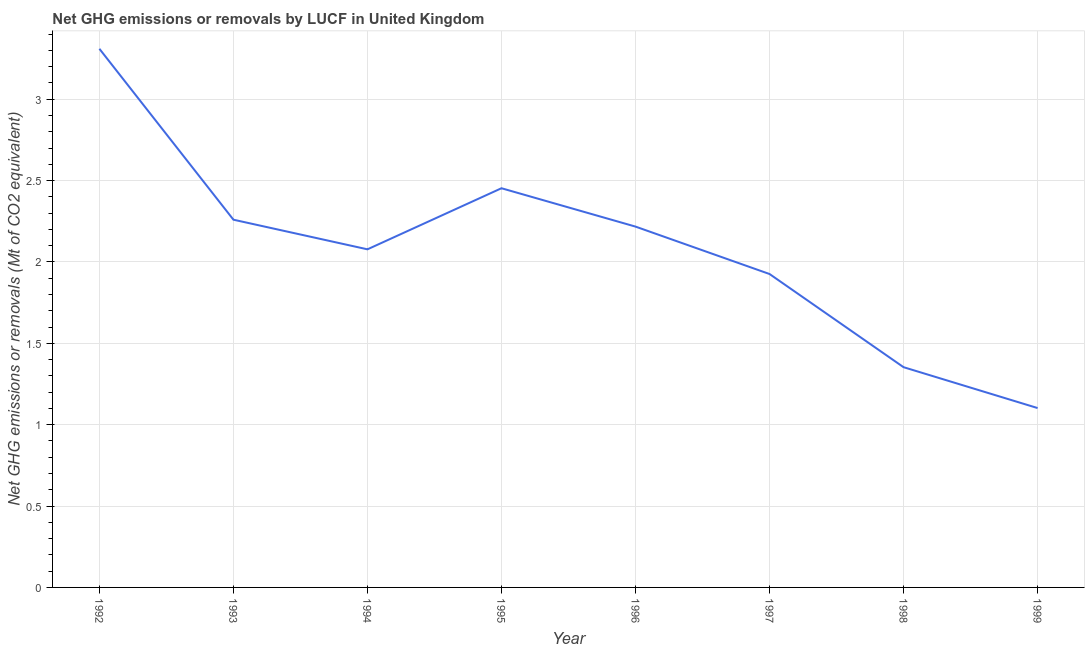What is the ghg net emissions or removals in 1996?
Keep it short and to the point. 2.22. Across all years, what is the maximum ghg net emissions or removals?
Ensure brevity in your answer.  3.31. Across all years, what is the minimum ghg net emissions or removals?
Your answer should be compact. 1.1. In which year was the ghg net emissions or removals maximum?
Make the answer very short. 1992. What is the sum of the ghg net emissions or removals?
Keep it short and to the point. 16.7. What is the difference between the ghg net emissions or removals in 1998 and 1999?
Offer a terse response. 0.25. What is the average ghg net emissions or removals per year?
Offer a very short reply. 2.09. What is the median ghg net emissions or removals?
Offer a very short reply. 2.15. In how many years, is the ghg net emissions or removals greater than 2.3 Mt?
Provide a succinct answer. 2. What is the ratio of the ghg net emissions or removals in 1992 to that in 1996?
Make the answer very short. 1.49. What is the difference between the highest and the second highest ghg net emissions or removals?
Offer a terse response. 0.86. What is the difference between the highest and the lowest ghg net emissions or removals?
Ensure brevity in your answer.  2.21. In how many years, is the ghg net emissions or removals greater than the average ghg net emissions or removals taken over all years?
Ensure brevity in your answer.  4. Are the values on the major ticks of Y-axis written in scientific E-notation?
Offer a very short reply. No. Does the graph contain any zero values?
Provide a succinct answer. No. Does the graph contain grids?
Keep it short and to the point. Yes. What is the title of the graph?
Your answer should be compact. Net GHG emissions or removals by LUCF in United Kingdom. What is the label or title of the Y-axis?
Offer a very short reply. Net GHG emissions or removals (Mt of CO2 equivalent). What is the Net GHG emissions or removals (Mt of CO2 equivalent) in 1992?
Offer a very short reply. 3.31. What is the Net GHG emissions or removals (Mt of CO2 equivalent) in 1993?
Your answer should be compact. 2.26. What is the Net GHG emissions or removals (Mt of CO2 equivalent) in 1994?
Keep it short and to the point. 2.08. What is the Net GHG emissions or removals (Mt of CO2 equivalent) of 1995?
Make the answer very short. 2.45. What is the Net GHG emissions or removals (Mt of CO2 equivalent) in 1996?
Keep it short and to the point. 2.22. What is the Net GHG emissions or removals (Mt of CO2 equivalent) in 1997?
Give a very brief answer. 1.93. What is the Net GHG emissions or removals (Mt of CO2 equivalent) of 1998?
Offer a terse response. 1.35. What is the Net GHG emissions or removals (Mt of CO2 equivalent) in 1999?
Your answer should be very brief. 1.1. What is the difference between the Net GHG emissions or removals (Mt of CO2 equivalent) in 1992 and 1993?
Give a very brief answer. 1.05. What is the difference between the Net GHG emissions or removals (Mt of CO2 equivalent) in 1992 and 1994?
Ensure brevity in your answer.  1.23. What is the difference between the Net GHG emissions or removals (Mt of CO2 equivalent) in 1992 and 1995?
Your answer should be very brief. 0.86. What is the difference between the Net GHG emissions or removals (Mt of CO2 equivalent) in 1992 and 1996?
Ensure brevity in your answer.  1.09. What is the difference between the Net GHG emissions or removals (Mt of CO2 equivalent) in 1992 and 1997?
Give a very brief answer. 1.38. What is the difference between the Net GHG emissions or removals (Mt of CO2 equivalent) in 1992 and 1998?
Make the answer very short. 1.96. What is the difference between the Net GHG emissions or removals (Mt of CO2 equivalent) in 1992 and 1999?
Provide a succinct answer. 2.21. What is the difference between the Net GHG emissions or removals (Mt of CO2 equivalent) in 1993 and 1994?
Provide a succinct answer. 0.18. What is the difference between the Net GHG emissions or removals (Mt of CO2 equivalent) in 1993 and 1995?
Your answer should be very brief. -0.19. What is the difference between the Net GHG emissions or removals (Mt of CO2 equivalent) in 1993 and 1996?
Provide a succinct answer. 0.04. What is the difference between the Net GHG emissions or removals (Mt of CO2 equivalent) in 1993 and 1997?
Provide a succinct answer. 0.33. What is the difference between the Net GHG emissions or removals (Mt of CO2 equivalent) in 1993 and 1998?
Your answer should be compact. 0.91. What is the difference between the Net GHG emissions or removals (Mt of CO2 equivalent) in 1993 and 1999?
Offer a terse response. 1.16. What is the difference between the Net GHG emissions or removals (Mt of CO2 equivalent) in 1994 and 1995?
Offer a terse response. -0.38. What is the difference between the Net GHG emissions or removals (Mt of CO2 equivalent) in 1994 and 1996?
Offer a terse response. -0.14. What is the difference between the Net GHG emissions or removals (Mt of CO2 equivalent) in 1994 and 1997?
Your response must be concise. 0.15. What is the difference between the Net GHG emissions or removals (Mt of CO2 equivalent) in 1994 and 1998?
Provide a short and direct response. 0.72. What is the difference between the Net GHG emissions or removals (Mt of CO2 equivalent) in 1994 and 1999?
Your response must be concise. 0.98. What is the difference between the Net GHG emissions or removals (Mt of CO2 equivalent) in 1995 and 1996?
Ensure brevity in your answer.  0.24. What is the difference between the Net GHG emissions or removals (Mt of CO2 equivalent) in 1995 and 1997?
Ensure brevity in your answer.  0.53. What is the difference between the Net GHG emissions or removals (Mt of CO2 equivalent) in 1995 and 1998?
Offer a very short reply. 1.1. What is the difference between the Net GHG emissions or removals (Mt of CO2 equivalent) in 1995 and 1999?
Offer a terse response. 1.35. What is the difference between the Net GHG emissions or removals (Mt of CO2 equivalent) in 1996 and 1997?
Provide a short and direct response. 0.29. What is the difference between the Net GHG emissions or removals (Mt of CO2 equivalent) in 1996 and 1998?
Your answer should be compact. 0.86. What is the difference between the Net GHG emissions or removals (Mt of CO2 equivalent) in 1996 and 1999?
Your answer should be very brief. 1.12. What is the difference between the Net GHG emissions or removals (Mt of CO2 equivalent) in 1997 and 1998?
Provide a succinct answer. 0.57. What is the difference between the Net GHG emissions or removals (Mt of CO2 equivalent) in 1997 and 1999?
Give a very brief answer. 0.82. What is the difference between the Net GHG emissions or removals (Mt of CO2 equivalent) in 1998 and 1999?
Offer a very short reply. 0.25. What is the ratio of the Net GHG emissions or removals (Mt of CO2 equivalent) in 1992 to that in 1993?
Your response must be concise. 1.47. What is the ratio of the Net GHG emissions or removals (Mt of CO2 equivalent) in 1992 to that in 1994?
Make the answer very short. 1.59. What is the ratio of the Net GHG emissions or removals (Mt of CO2 equivalent) in 1992 to that in 1995?
Your response must be concise. 1.35. What is the ratio of the Net GHG emissions or removals (Mt of CO2 equivalent) in 1992 to that in 1996?
Your answer should be very brief. 1.49. What is the ratio of the Net GHG emissions or removals (Mt of CO2 equivalent) in 1992 to that in 1997?
Give a very brief answer. 1.72. What is the ratio of the Net GHG emissions or removals (Mt of CO2 equivalent) in 1992 to that in 1998?
Your response must be concise. 2.45. What is the ratio of the Net GHG emissions or removals (Mt of CO2 equivalent) in 1992 to that in 1999?
Ensure brevity in your answer.  3. What is the ratio of the Net GHG emissions or removals (Mt of CO2 equivalent) in 1993 to that in 1994?
Make the answer very short. 1.09. What is the ratio of the Net GHG emissions or removals (Mt of CO2 equivalent) in 1993 to that in 1995?
Provide a succinct answer. 0.92. What is the ratio of the Net GHG emissions or removals (Mt of CO2 equivalent) in 1993 to that in 1996?
Make the answer very short. 1.02. What is the ratio of the Net GHG emissions or removals (Mt of CO2 equivalent) in 1993 to that in 1997?
Make the answer very short. 1.17. What is the ratio of the Net GHG emissions or removals (Mt of CO2 equivalent) in 1993 to that in 1998?
Provide a short and direct response. 1.67. What is the ratio of the Net GHG emissions or removals (Mt of CO2 equivalent) in 1993 to that in 1999?
Offer a very short reply. 2.05. What is the ratio of the Net GHG emissions or removals (Mt of CO2 equivalent) in 1994 to that in 1995?
Provide a short and direct response. 0.85. What is the ratio of the Net GHG emissions or removals (Mt of CO2 equivalent) in 1994 to that in 1996?
Offer a very short reply. 0.94. What is the ratio of the Net GHG emissions or removals (Mt of CO2 equivalent) in 1994 to that in 1997?
Make the answer very short. 1.08. What is the ratio of the Net GHG emissions or removals (Mt of CO2 equivalent) in 1994 to that in 1998?
Give a very brief answer. 1.53. What is the ratio of the Net GHG emissions or removals (Mt of CO2 equivalent) in 1994 to that in 1999?
Keep it short and to the point. 1.89. What is the ratio of the Net GHG emissions or removals (Mt of CO2 equivalent) in 1995 to that in 1996?
Ensure brevity in your answer.  1.11. What is the ratio of the Net GHG emissions or removals (Mt of CO2 equivalent) in 1995 to that in 1997?
Offer a very short reply. 1.27. What is the ratio of the Net GHG emissions or removals (Mt of CO2 equivalent) in 1995 to that in 1998?
Offer a very short reply. 1.81. What is the ratio of the Net GHG emissions or removals (Mt of CO2 equivalent) in 1995 to that in 1999?
Your answer should be very brief. 2.23. What is the ratio of the Net GHG emissions or removals (Mt of CO2 equivalent) in 1996 to that in 1997?
Provide a short and direct response. 1.15. What is the ratio of the Net GHG emissions or removals (Mt of CO2 equivalent) in 1996 to that in 1998?
Offer a terse response. 1.64. What is the ratio of the Net GHG emissions or removals (Mt of CO2 equivalent) in 1996 to that in 1999?
Provide a short and direct response. 2.01. What is the ratio of the Net GHG emissions or removals (Mt of CO2 equivalent) in 1997 to that in 1998?
Your response must be concise. 1.42. What is the ratio of the Net GHG emissions or removals (Mt of CO2 equivalent) in 1997 to that in 1999?
Offer a terse response. 1.75. What is the ratio of the Net GHG emissions or removals (Mt of CO2 equivalent) in 1998 to that in 1999?
Provide a short and direct response. 1.23. 